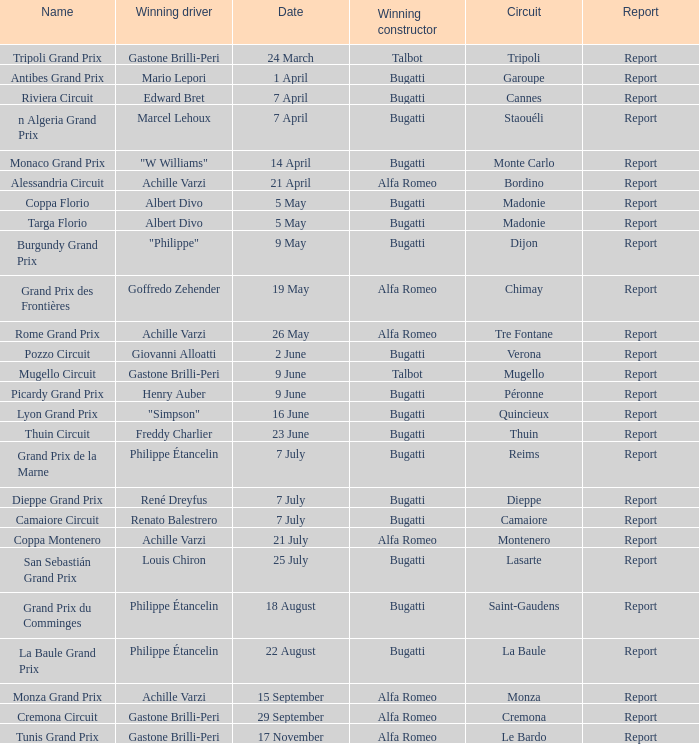What Date has a Name of thuin circuit? 23 June. 